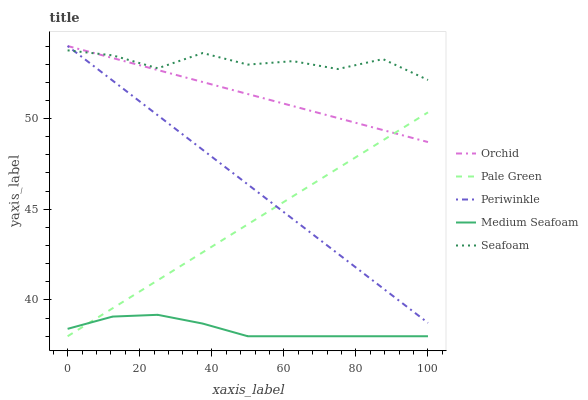Does Medium Seafoam have the minimum area under the curve?
Answer yes or no. Yes. Does Seafoam have the maximum area under the curve?
Answer yes or no. Yes. Does Pale Green have the minimum area under the curve?
Answer yes or no. No. Does Pale Green have the maximum area under the curve?
Answer yes or no. No. Is Periwinkle the smoothest?
Answer yes or no. Yes. Is Seafoam the roughest?
Answer yes or no. Yes. Is Pale Green the smoothest?
Answer yes or no. No. Is Pale Green the roughest?
Answer yes or no. No. Does Pale Green have the lowest value?
Answer yes or no. Yes. Does Periwinkle have the lowest value?
Answer yes or no. No. Does Orchid have the highest value?
Answer yes or no. Yes. Does Pale Green have the highest value?
Answer yes or no. No. Is Medium Seafoam less than Periwinkle?
Answer yes or no. Yes. Is Periwinkle greater than Medium Seafoam?
Answer yes or no. Yes. Does Orchid intersect Seafoam?
Answer yes or no. Yes. Is Orchid less than Seafoam?
Answer yes or no. No. Is Orchid greater than Seafoam?
Answer yes or no. No. Does Medium Seafoam intersect Periwinkle?
Answer yes or no. No. 